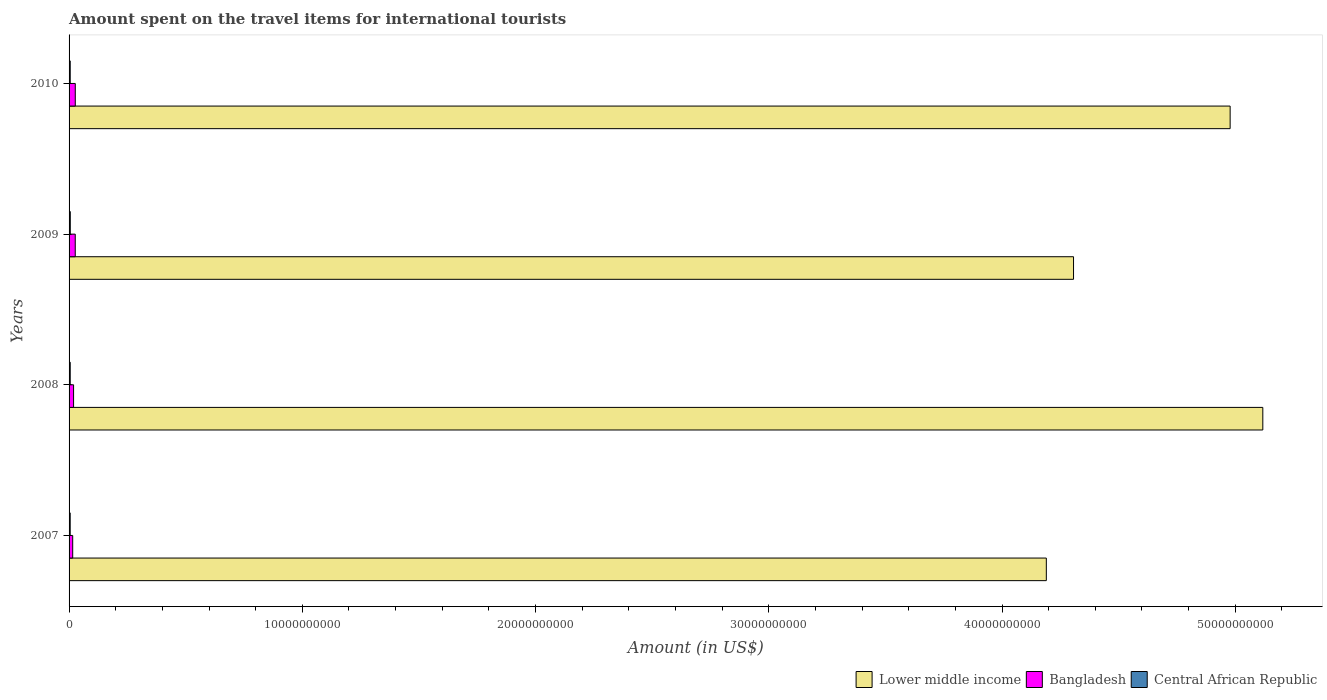How many different coloured bars are there?
Ensure brevity in your answer.  3. How many groups of bars are there?
Your response must be concise. 4. Are the number of bars per tick equal to the number of legend labels?
Offer a terse response. Yes. How many bars are there on the 2nd tick from the top?
Offer a terse response. 3. What is the label of the 1st group of bars from the top?
Provide a succinct answer. 2010. What is the amount spent on the travel items for international tourists in Central African Republic in 2009?
Ensure brevity in your answer.  5.20e+07. Across all years, what is the maximum amount spent on the travel items for international tourists in Bangladesh?
Give a very brief answer. 2.66e+08. Across all years, what is the minimum amount spent on the travel items for international tourists in Lower middle income?
Keep it short and to the point. 4.19e+1. In which year was the amount spent on the travel items for international tourists in Central African Republic maximum?
Ensure brevity in your answer.  2009. What is the total amount spent on the travel items for international tourists in Lower middle income in the graph?
Provide a short and direct response. 1.86e+11. What is the difference between the amount spent on the travel items for international tourists in Lower middle income in 2007 and that in 2009?
Keep it short and to the point. -1.17e+09. What is the difference between the amount spent on the travel items for international tourists in Central African Republic in 2009 and the amount spent on the travel items for international tourists in Lower middle income in 2008?
Make the answer very short. -5.11e+1. What is the average amount spent on the travel items for international tourists in Central African Republic per year?
Offer a very short reply. 4.95e+07. In the year 2009, what is the difference between the amount spent on the travel items for international tourists in Lower middle income and amount spent on the travel items for international tourists in Central African Republic?
Keep it short and to the point. 4.30e+1. What is the ratio of the amount spent on the travel items for international tourists in Central African Republic in 2009 to that in 2010?
Keep it short and to the point. 1.06. Is the amount spent on the travel items for international tourists in Central African Republic in 2007 less than that in 2008?
Give a very brief answer. Yes. Is the difference between the amount spent on the travel items for international tourists in Lower middle income in 2007 and 2009 greater than the difference between the amount spent on the travel items for international tourists in Central African Republic in 2007 and 2009?
Make the answer very short. No. What is the difference between the highest and the second highest amount spent on the travel items for international tourists in Lower middle income?
Give a very brief answer. 1.40e+09. What is the difference between the highest and the lowest amount spent on the travel items for international tourists in Central African Republic?
Keep it short and to the point. 4.00e+06. In how many years, is the amount spent on the travel items for international tourists in Lower middle income greater than the average amount spent on the travel items for international tourists in Lower middle income taken over all years?
Make the answer very short. 2. What does the 1st bar from the bottom in 2009 represents?
Keep it short and to the point. Lower middle income. Is it the case that in every year, the sum of the amount spent on the travel items for international tourists in Central African Republic and amount spent on the travel items for international tourists in Lower middle income is greater than the amount spent on the travel items for international tourists in Bangladesh?
Offer a terse response. Yes. How many bars are there?
Your response must be concise. 12. How many years are there in the graph?
Your response must be concise. 4. Does the graph contain any zero values?
Provide a succinct answer. No. Does the graph contain grids?
Offer a terse response. No. Where does the legend appear in the graph?
Your answer should be compact. Bottom right. How are the legend labels stacked?
Ensure brevity in your answer.  Horizontal. What is the title of the graph?
Provide a short and direct response. Amount spent on the travel items for international tourists. Does "Moldova" appear as one of the legend labels in the graph?
Provide a succinct answer. No. What is the label or title of the Y-axis?
Offer a very short reply. Years. What is the Amount (in US$) of Lower middle income in 2007?
Your answer should be compact. 4.19e+1. What is the Amount (in US$) in Bangladesh in 2007?
Your answer should be very brief. 1.56e+08. What is the Amount (in US$) in Central African Republic in 2007?
Offer a terse response. 4.80e+07. What is the Amount (in US$) of Lower middle income in 2008?
Give a very brief answer. 5.12e+1. What is the Amount (in US$) in Bangladesh in 2008?
Offer a terse response. 1.93e+08. What is the Amount (in US$) in Central African Republic in 2008?
Give a very brief answer. 4.90e+07. What is the Amount (in US$) in Lower middle income in 2009?
Your answer should be very brief. 4.31e+1. What is the Amount (in US$) in Bangladesh in 2009?
Your answer should be compact. 2.65e+08. What is the Amount (in US$) of Central African Republic in 2009?
Your answer should be compact. 5.20e+07. What is the Amount (in US$) of Lower middle income in 2010?
Give a very brief answer. 4.98e+1. What is the Amount (in US$) in Bangladesh in 2010?
Offer a very short reply. 2.66e+08. What is the Amount (in US$) in Central African Republic in 2010?
Make the answer very short. 4.90e+07. Across all years, what is the maximum Amount (in US$) in Lower middle income?
Keep it short and to the point. 5.12e+1. Across all years, what is the maximum Amount (in US$) of Bangladesh?
Ensure brevity in your answer.  2.66e+08. Across all years, what is the maximum Amount (in US$) in Central African Republic?
Give a very brief answer. 5.20e+07. Across all years, what is the minimum Amount (in US$) in Lower middle income?
Keep it short and to the point. 4.19e+1. Across all years, what is the minimum Amount (in US$) of Bangladesh?
Offer a terse response. 1.56e+08. Across all years, what is the minimum Amount (in US$) of Central African Republic?
Your answer should be very brief. 4.80e+07. What is the total Amount (in US$) in Lower middle income in the graph?
Your response must be concise. 1.86e+11. What is the total Amount (in US$) in Bangladesh in the graph?
Your response must be concise. 8.80e+08. What is the total Amount (in US$) in Central African Republic in the graph?
Give a very brief answer. 1.98e+08. What is the difference between the Amount (in US$) of Lower middle income in 2007 and that in 2008?
Give a very brief answer. -9.28e+09. What is the difference between the Amount (in US$) in Bangladesh in 2007 and that in 2008?
Provide a succinct answer. -3.70e+07. What is the difference between the Amount (in US$) in Lower middle income in 2007 and that in 2009?
Provide a succinct answer. -1.17e+09. What is the difference between the Amount (in US$) of Bangladesh in 2007 and that in 2009?
Provide a short and direct response. -1.09e+08. What is the difference between the Amount (in US$) in Central African Republic in 2007 and that in 2009?
Ensure brevity in your answer.  -4.00e+06. What is the difference between the Amount (in US$) in Lower middle income in 2007 and that in 2010?
Your answer should be very brief. -7.88e+09. What is the difference between the Amount (in US$) in Bangladesh in 2007 and that in 2010?
Give a very brief answer. -1.10e+08. What is the difference between the Amount (in US$) of Central African Republic in 2007 and that in 2010?
Give a very brief answer. -1.00e+06. What is the difference between the Amount (in US$) of Lower middle income in 2008 and that in 2009?
Make the answer very short. 8.12e+09. What is the difference between the Amount (in US$) of Bangladesh in 2008 and that in 2009?
Your response must be concise. -7.20e+07. What is the difference between the Amount (in US$) in Lower middle income in 2008 and that in 2010?
Make the answer very short. 1.40e+09. What is the difference between the Amount (in US$) in Bangladesh in 2008 and that in 2010?
Your answer should be compact. -7.30e+07. What is the difference between the Amount (in US$) of Lower middle income in 2009 and that in 2010?
Make the answer very short. -6.72e+09. What is the difference between the Amount (in US$) of Central African Republic in 2009 and that in 2010?
Offer a terse response. 3.00e+06. What is the difference between the Amount (in US$) in Lower middle income in 2007 and the Amount (in US$) in Bangladesh in 2008?
Your response must be concise. 4.17e+1. What is the difference between the Amount (in US$) in Lower middle income in 2007 and the Amount (in US$) in Central African Republic in 2008?
Give a very brief answer. 4.19e+1. What is the difference between the Amount (in US$) in Bangladesh in 2007 and the Amount (in US$) in Central African Republic in 2008?
Provide a succinct answer. 1.07e+08. What is the difference between the Amount (in US$) in Lower middle income in 2007 and the Amount (in US$) in Bangladesh in 2009?
Provide a short and direct response. 4.16e+1. What is the difference between the Amount (in US$) of Lower middle income in 2007 and the Amount (in US$) of Central African Republic in 2009?
Give a very brief answer. 4.18e+1. What is the difference between the Amount (in US$) of Bangladesh in 2007 and the Amount (in US$) of Central African Republic in 2009?
Your response must be concise. 1.04e+08. What is the difference between the Amount (in US$) in Lower middle income in 2007 and the Amount (in US$) in Bangladesh in 2010?
Your answer should be very brief. 4.16e+1. What is the difference between the Amount (in US$) in Lower middle income in 2007 and the Amount (in US$) in Central African Republic in 2010?
Make the answer very short. 4.19e+1. What is the difference between the Amount (in US$) of Bangladesh in 2007 and the Amount (in US$) of Central African Republic in 2010?
Your answer should be very brief. 1.07e+08. What is the difference between the Amount (in US$) in Lower middle income in 2008 and the Amount (in US$) in Bangladesh in 2009?
Provide a short and direct response. 5.09e+1. What is the difference between the Amount (in US$) in Lower middle income in 2008 and the Amount (in US$) in Central African Republic in 2009?
Your answer should be very brief. 5.11e+1. What is the difference between the Amount (in US$) of Bangladesh in 2008 and the Amount (in US$) of Central African Republic in 2009?
Give a very brief answer. 1.41e+08. What is the difference between the Amount (in US$) of Lower middle income in 2008 and the Amount (in US$) of Bangladesh in 2010?
Provide a succinct answer. 5.09e+1. What is the difference between the Amount (in US$) of Lower middle income in 2008 and the Amount (in US$) of Central African Republic in 2010?
Your answer should be compact. 5.11e+1. What is the difference between the Amount (in US$) of Bangladesh in 2008 and the Amount (in US$) of Central African Republic in 2010?
Give a very brief answer. 1.44e+08. What is the difference between the Amount (in US$) in Lower middle income in 2009 and the Amount (in US$) in Bangladesh in 2010?
Provide a succinct answer. 4.28e+1. What is the difference between the Amount (in US$) of Lower middle income in 2009 and the Amount (in US$) of Central African Republic in 2010?
Provide a short and direct response. 4.30e+1. What is the difference between the Amount (in US$) in Bangladesh in 2009 and the Amount (in US$) in Central African Republic in 2010?
Keep it short and to the point. 2.16e+08. What is the average Amount (in US$) in Lower middle income per year?
Your response must be concise. 4.65e+1. What is the average Amount (in US$) in Bangladesh per year?
Your answer should be very brief. 2.20e+08. What is the average Amount (in US$) in Central African Republic per year?
Make the answer very short. 4.95e+07. In the year 2007, what is the difference between the Amount (in US$) in Lower middle income and Amount (in US$) in Bangladesh?
Offer a terse response. 4.17e+1. In the year 2007, what is the difference between the Amount (in US$) in Lower middle income and Amount (in US$) in Central African Republic?
Give a very brief answer. 4.19e+1. In the year 2007, what is the difference between the Amount (in US$) in Bangladesh and Amount (in US$) in Central African Republic?
Give a very brief answer. 1.08e+08. In the year 2008, what is the difference between the Amount (in US$) of Lower middle income and Amount (in US$) of Bangladesh?
Keep it short and to the point. 5.10e+1. In the year 2008, what is the difference between the Amount (in US$) of Lower middle income and Amount (in US$) of Central African Republic?
Your answer should be compact. 5.11e+1. In the year 2008, what is the difference between the Amount (in US$) of Bangladesh and Amount (in US$) of Central African Republic?
Provide a short and direct response. 1.44e+08. In the year 2009, what is the difference between the Amount (in US$) in Lower middle income and Amount (in US$) in Bangladesh?
Provide a succinct answer. 4.28e+1. In the year 2009, what is the difference between the Amount (in US$) of Lower middle income and Amount (in US$) of Central African Republic?
Provide a succinct answer. 4.30e+1. In the year 2009, what is the difference between the Amount (in US$) of Bangladesh and Amount (in US$) of Central African Republic?
Provide a short and direct response. 2.13e+08. In the year 2010, what is the difference between the Amount (in US$) in Lower middle income and Amount (in US$) in Bangladesh?
Your answer should be compact. 4.95e+1. In the year 2010, what is the difference between the Amount (in US$) in Lower middle income and Amount (in US$) in Central African Republic?
Your answer should be very brief. 4.97e+1. In the year 2010, what is the difference between the Amount (in US$) in Bangladesh and Amount (in US$) in Central African Republic?
Provide a short and direct response. 2.17e+08. What is the ratio of the Amount (in US$) of Lower middle income in 2007 to that in 2008?
Keep it short and to the point. 0.82. What is the ratio of the Amount (in US$) in Bangladesh in 2007 to that in 2008?
Your answer should be compact. 0.81. What is the ratio of the Amount (in US$) in Central African Republic in 2007 to that in 2008?
Ensure brevity in your answer.  0.98. What is the ratio of the Amount (in US$) of Lower middle income in 2007 to that in 2009?
Your response must be concise. 0.97. What is the ratio of the Amount (in US$) of Bangladesh in 2007 to that in 2009?
Make the answer very short. 0.59. What is the ratio of the Amount (in US$) of Lower middle income in 2007 to that in 2010?
Ensure brevity in your answer.  0.84. What is the ratio of the Amount (in US$) in Bangladesh in 2007 to that in 2010?
Your answer should be compact. 0.59. What is the ratio of the Amount (in US$) of Central African Republic in 2007 to that in 2010?
Provide a succinct answer. 0.98. What is the ratio of the Amount (in US$) in Lower middle income in 2008 to that in 2009?
Your response must be concise. 1.19. What is the ratio of the Amount (in US$) of Bangladesh in 2008 to that in 2009?
Make the answer very short. 0.73. What is the ratio of the Amount (in US$) of Central African Republic in 2008 to that in 2009?
Make the answer very short. 0.94. What is the ratio of the Amount (in US$) of Lower middle income in 2008 to that in 2010?
Offer a terse response. 1.03. What is the ratio of the Amount (in US$) in Bangladesh in 2008 to that in 2010?
Keep it short and to the point. 0.73. What is the ratio of the Amount (in US$) of Central African Republic in 2008 to that in 2010?
Ensure brevity in your answer.  1. What is the ratio of the Amount (in US$) of Lower middle income in 2009 to that in 2010?
Your response must be concise. 0.87. What is the ratio of the Amount (in US$) in Central African Republic in 2009 to that in 2010?
Ensure brevity in your answer.  1.06. What is the difference between the highest and the second highest Amount (in US$) of Lower middle income?
Provide a short and direct response. 1.40e+09. What is the difference between the highest and the second highest Amount (in US$) of Bangladesh?
Offer a terse response. 1.00e+06. What is the difference between the highest and the lowest Amount (in US$) of Lower middle income?
Keep it short and to the point. 9.28e+09. What is the difference between the highest and the lowest Amount (in US$) in Bangladesh?
Make the answer very short. 1.10e+08. 